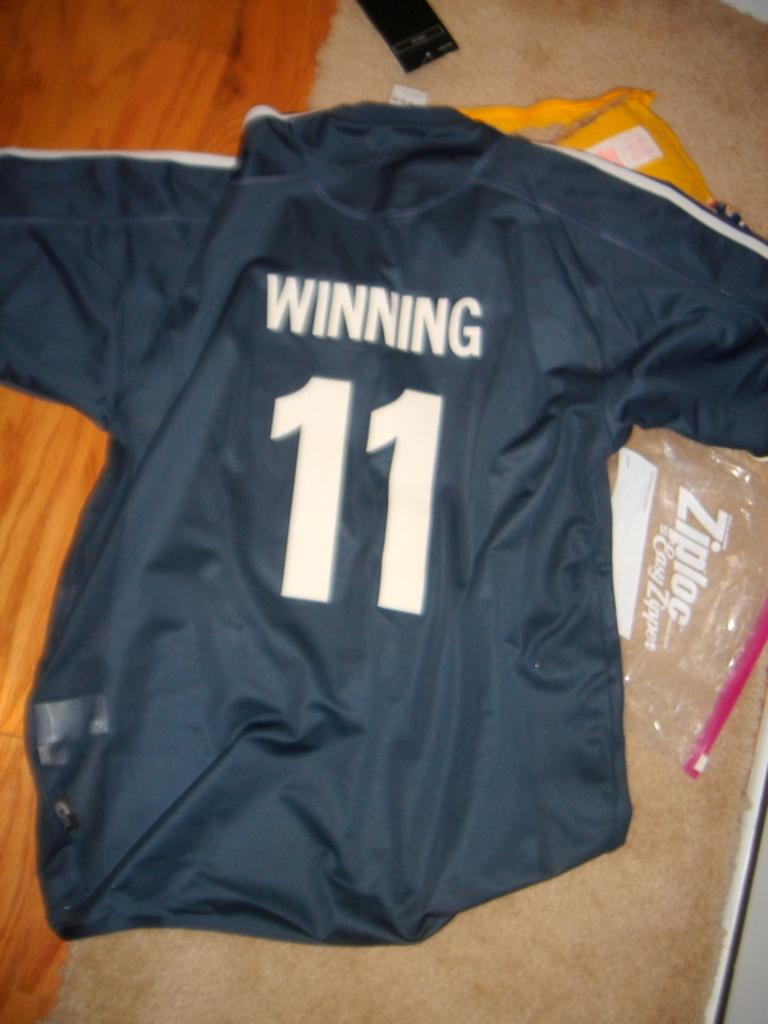<image>
Describe the image concisely. A team shirt has the number 11 on it underneath the word Winning. 